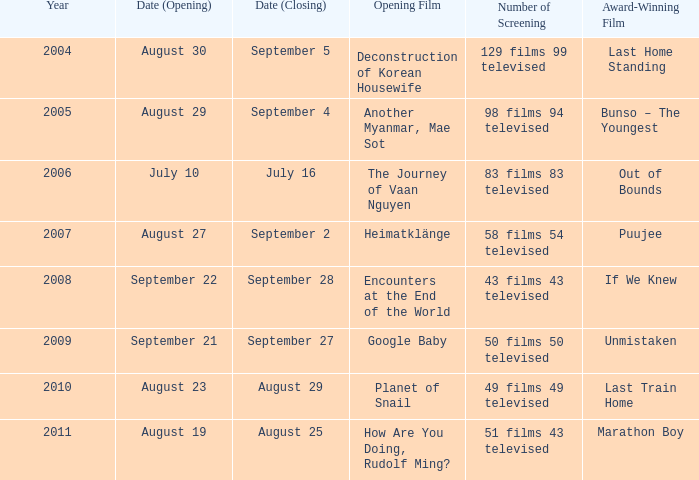Which debut film has the launch date of august 23? Planet of Snail. Would you be able to parse every entry in this table? {'header': ['Year', 'Date (Opening)', 'Date (Closing)', 'Opening Film', 'Number of Screening', 'Award-Winning Film'], 'rows': [['2004', 'August 30', 'September 5', 'Deconstruction of Korean Housewife', '129 films 99 televised', 'Last Home Standing'], ['2005', 'August 29', 'September 4', 'Another Myanmar, Mae Sot', '98 films 94 televised', 'Bunso – The Youngest'], ['2006', 'July 10', 'July 16', 'The Journey of Vaan Nguyen', '83 films 83 televised', 'Out of Bounds'], ['2007', 'August 27', 'September 2', 'Heimatklänge', '58 films 54 televised', 'Puujee'], ['2008', 'September 22', 'September 28', 'Encounters at the End of the World', '43 films 43 televised', 'If We Knew'], ['2009', 'September 21', 'September 27', 'Google Baby', '50 films 50 televised', 'Unmistaken'], ['2010', 'August 23', 'August 29', 'Planet of Snail', '49 films 49 televised', 'Last Train Home'], ['2011', 'August 19', 'August 25', 'How Are You Doing, Rudolf Ming?', '51 films 43 televised', 'Marathon Boy']]} 